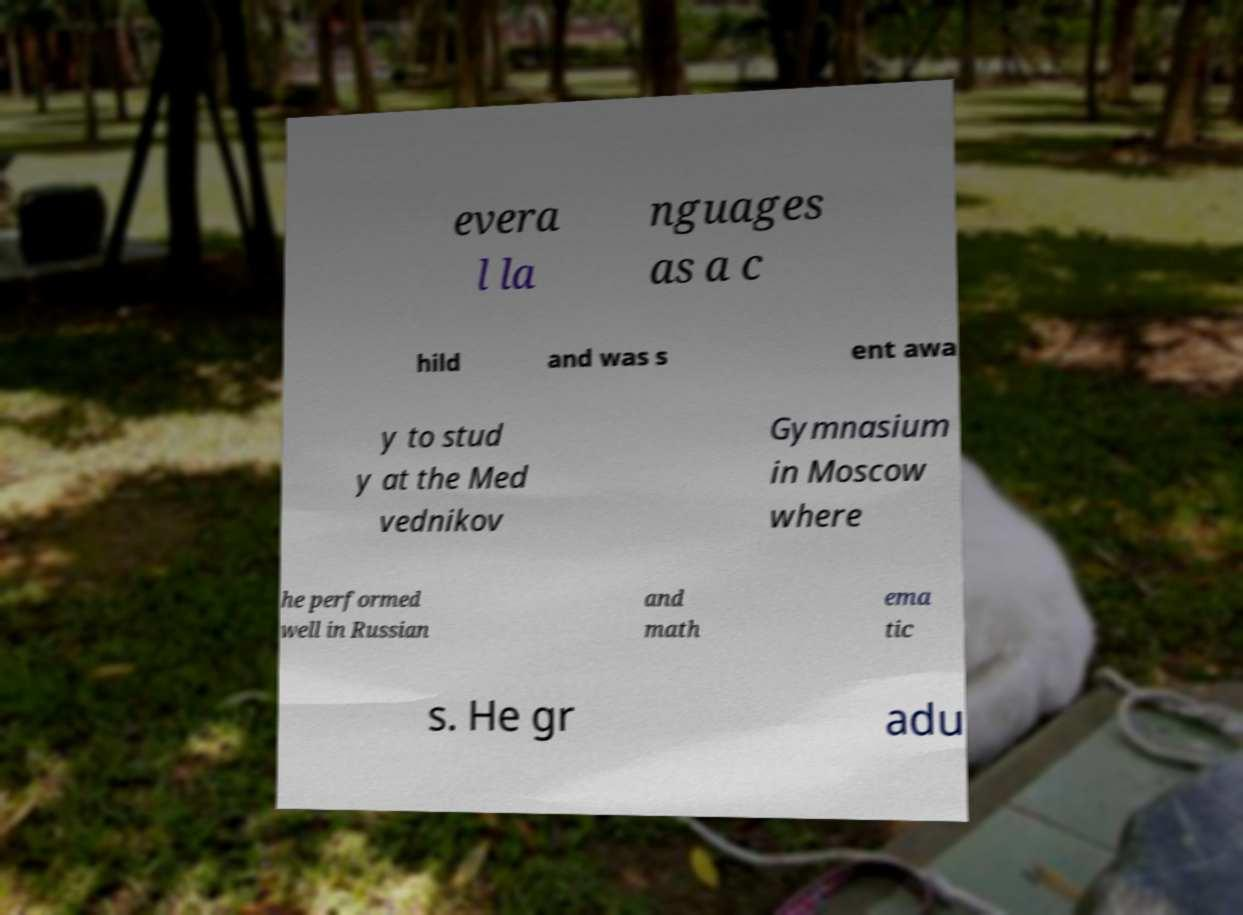For documentation purposes, I need the text within this image transcribed. Could you provide that? evera l la nguages as a c hild and was s ent awa y to stud y at the Med vednikov Gymnasium in Moscow where he performed well in Russian and math ema tic s. He gr adu 